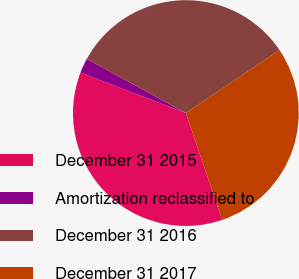Convert chart. <chart><loc_0><loc_0><loc_500><loc_500><pie_chart><fcel>December 31 2015<fcel>Amortization reclassified to<fcel>December 31 2016<fcel>December 31 2017<nl><fcel>36.06%<fcel>2.12%<fcel>32.61%<fcel>29.21%<nl></chart> 